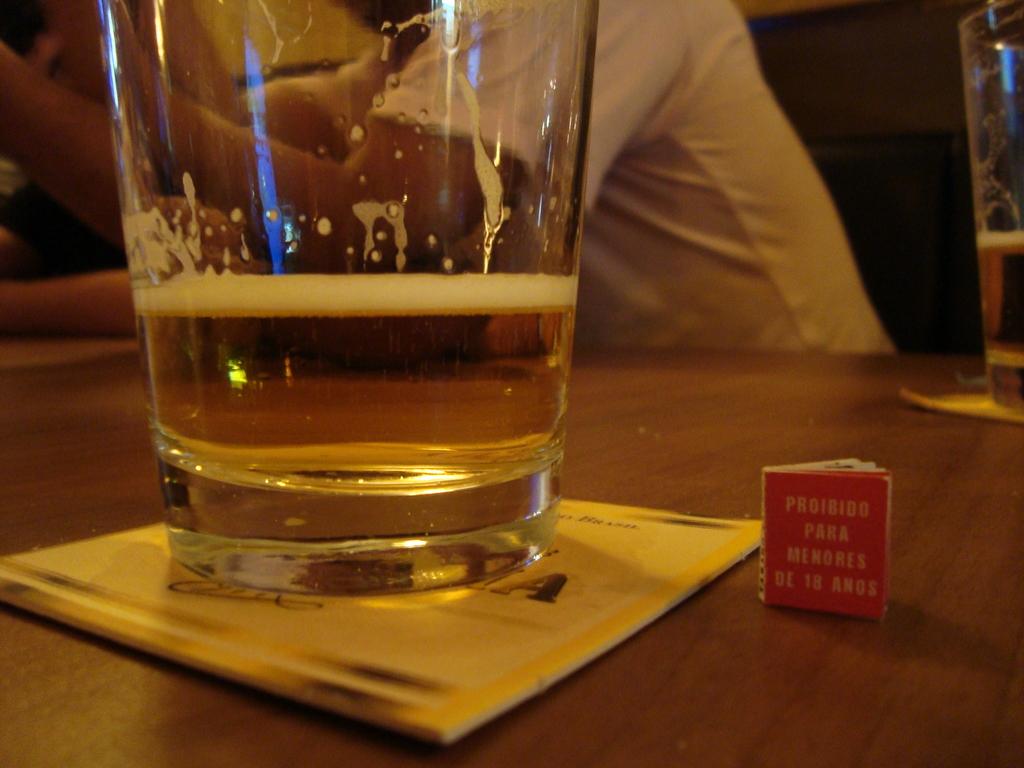How old is this prohibited to?
Make the answer very short. 18. 